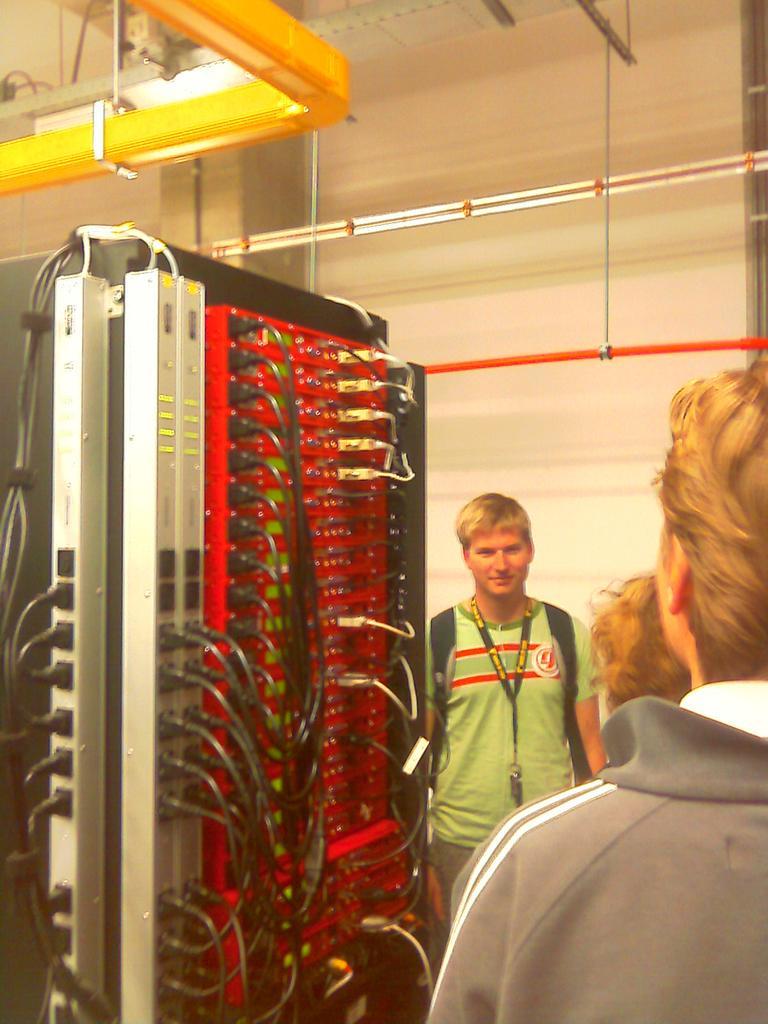Could you give a brief overview of what you see in this image? In this image I can see three persons are standing on the floor and wires board. On the top I can see a rooftop, wall and pipes. This image is taken in a hall. 